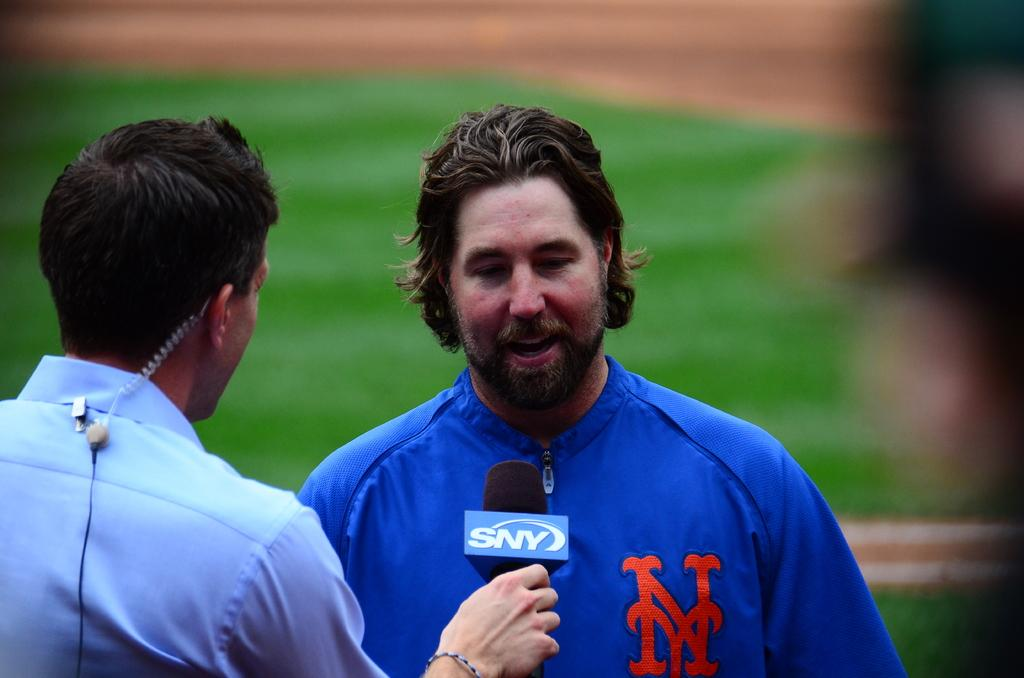<image>
Describe the image concisely. A man wearing a jacket with NY on it is being interviewed. 